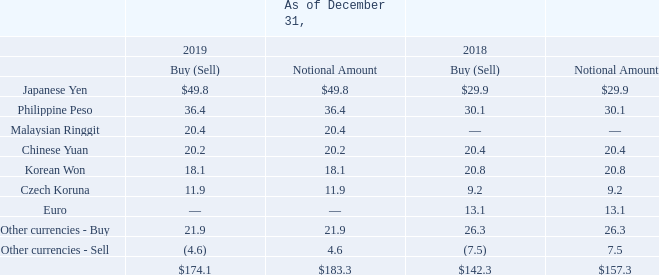Foreign Currencies
As a multinational business, the Company's transactions are denominated in a variety of currencies. When appropriate, the Company uses forward foreign currency contracts to reduce its overall exposure to the effects of currency fluctuations on its results of operations and cash flows. The Company's policy prohibits trading in currencies for which there are no underlying exposures and entering into trades for any currency to intentionally increase the underlying exposure.
The Company primarily hedges existing assets and liabilities associated with transactions currently on its balance sheet, which are undesignated hedges for accounting purposes.
As of December 31, 2019 and 2018, the Company had net outstanding foreign exchange contracts with net notional amounts of $183.3 million and $157.3 million, respectively. Such contracts were obtained through financial institutions and were scheduled to mature within one to three months from the time of purchase.
Management believes that these financial instruments should not subject the Company to increased risks from foreign exchange movements because gains and losses on these contracts should offset losses and gains on the underlying assets, liabilities and transactions to which they are related.
The following schedule summarizes the Company's net foreign exchange positions in U.S. dollars (in millions):
Amounts receivable or payable under the contracts are included in other current assets or accrued expenses in the accompanying Consolidated Balance Sheets. For the years ended December 31, 2019, 2018 and 2017, realized and unrealized foreign currency transactions totaled a loss of $5.0 million, $8.0 million and $6.3 million, respectively. The realized and unrealized foreign currency transactions are included in other income and expenses in the Company's Consolidated Statements of Operations and Comprehensive Income.
What was the net notional amount of net outstanding foreign exchange contracts as of December 31, 2019? $183.3 million. What was the net notional amount of net outstanding foreign exchange contracts as of December 31, 2018? $157.3 million. How much was the loss of realized and unrealized foreign currency transactions for the years ended December 31, 2019, 2018 and 2017 respectively? $5.0 million, $8.0 million, $6.3 million. What is the change in the Japanese Yen Buy position from December 31, 2018 to 2019?
Answer scale should be: million. 49.8-29.9
Answer: 19.9. What is the change in Philippine Peso Buy position from year ended December 31, 2018 to 2019?
Answer scale should be: million. 36.4-30.1
Answer: 6.3. What is the average Japanese Yen Buy position for December 31, 2018 and 2019?
Answer scale should be: million. (49.8+29.9) / 2
Answer: 39.85. 